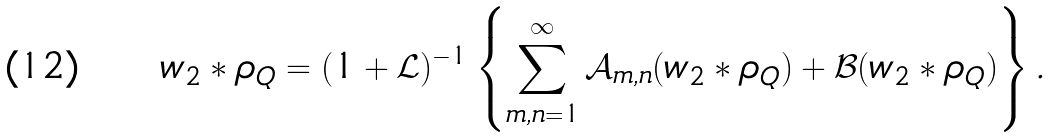<formula> <loc_0><loc_0><loc_500><loc_500>w _ { 2 } * \rho _ { Q } = ( 1 + \mathcal { L } ) ^ { - 1 } \left \{ \sum _ { m , n = 1 } ^ { \infty } \mathcal { A } _ { m , n } ( w _ { 2 } * \rho _ { Q } ) + \mathcal { B } ( w _ { 2 } * \rho _ { Q } ) \right \} .</formula> 